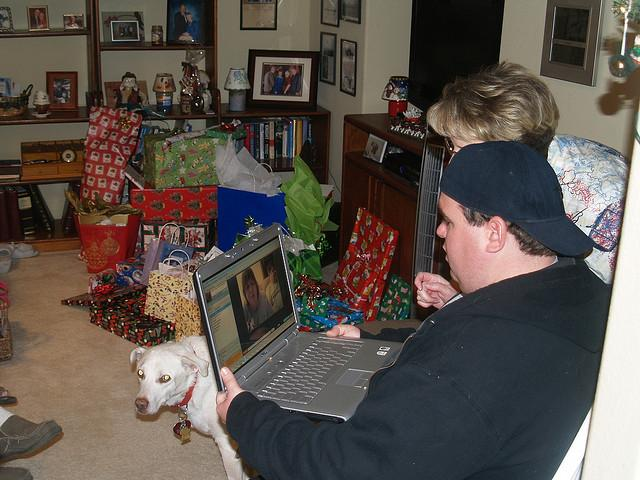What came in all those colored boxes?

Choices:
A) blankets
B) carpet
C) food
D) presents presents 